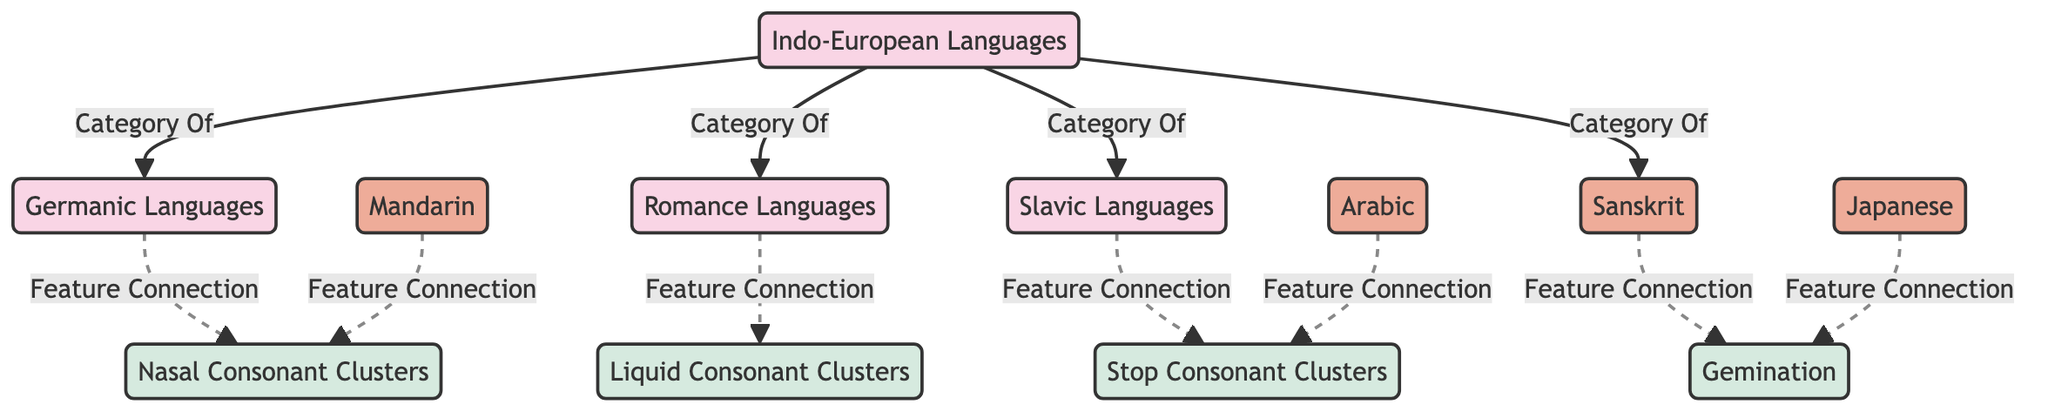What is the total number of language families represented in the diagram? The diagram shows a total of four language families: Indo-European, Germanic, Romance, and Slavic. We count the nodes in the "Language Families" group and find four distinct entries.
Answer: 4 Which language family connects to liquid consonant clusters? The Romance languages are the language family associated with liquid consonant clusters. This connection is indicated by the line labeled "Feature Connection" from Romance to LiquidCluster.
Answer: Romance What type of phonetic feature is connected to the Slavic languages? The Slavic languages are connected to stop consonant clusters, as indicated by the edge labeled "Feature Connection" leading from Slavic to StopClusters.
Answer: Stop Consonant Clusters Which language family includes Sanskrit? Sanskrit is a member of the Indo-European language family, illustrated by the direct line connecting IndoEuropean to Sanskrit marked "Category Of."
Answer: Indo-European Languages How many language families have a connection to gemination? There are two connections to gemination: one from Sanskrit and one from Japanese, both of which are linked to the Gemination feature. Thus, two language families are connected to gemination.
Answer: 2 Which two languages are associated with nasal consonant clusters? The languages associated with nasal consonant clusters are Germanic and Mandarin, as shown by the connections labeled "Feature Connection" from both languages to NasalCluster.
Answer: Germanic and Mandarin Which phonetic feature is linked to the Arabic language? The Arabic language is associated with stop consonant clusters, with the connection explicitly marked as "Feature Connection" from Arabic to StopClusters.
Answer: Stop Consonant Clusters What is the relationship between Indo-European languages and Sanskrit? The relationship is that Sanskrit is categorized as part of the Indo-European language family, demonstrated by the edge labeled "Category Of" leading from IndoEuropean to Sanskrit.
Answer: Category Of How many feature connections are displayed on the diagram? There are six feature connections illustrated in total, shown by counting the edges connecting specific languages to their respective phonetic features.
Answer: 6 